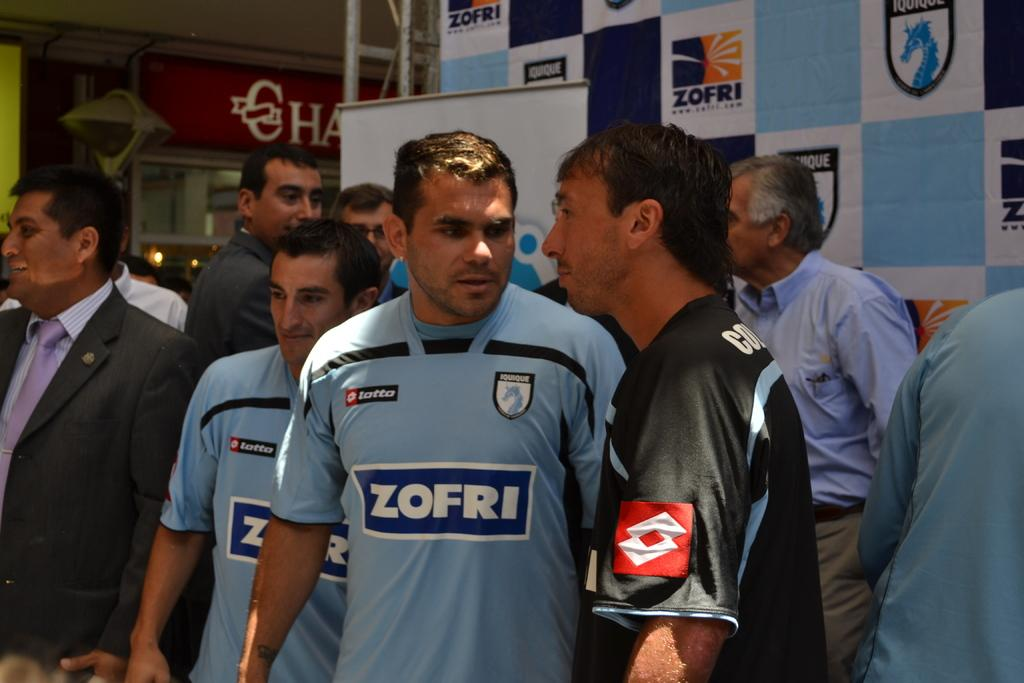<image>
Write a terse but informative summary of the picture. A group of athletes talking near a blue Zofri billboard. 